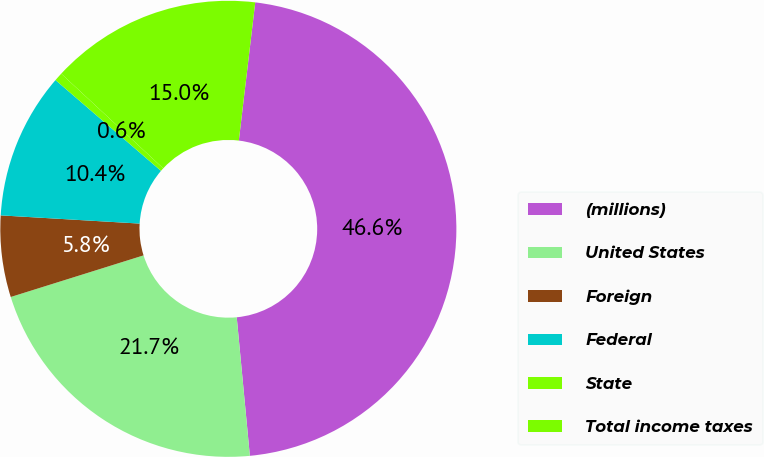Convert chart to OTSL. <chart><loc_0><loc_0><loc_500><loc_500><pie_chart><fcel>(millions)<fcel>United States<fcel>Foreign<fcel>Federal<fcel>State<fcel>Total income taxes<nl><fcel>46.61%<fcel>21.67%<fcel>5.77%<fcel>10.37%<fcel>0.6%<fcel>14.97%<nl></chart> 